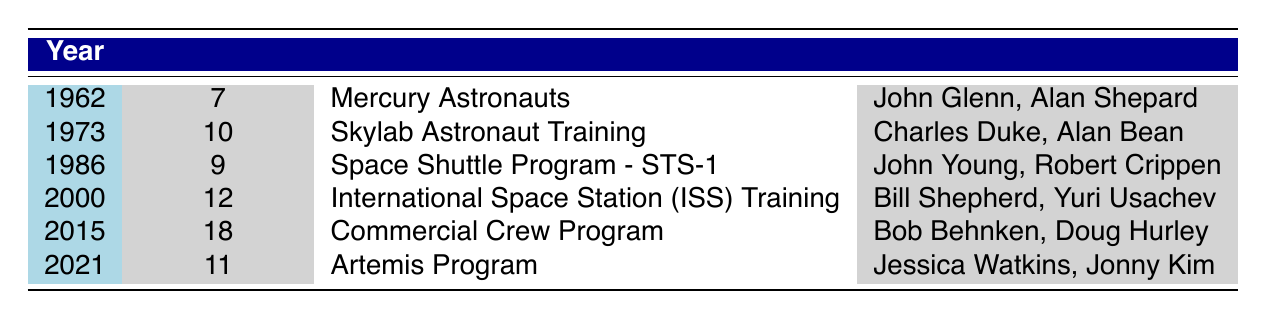What was the maximum number of participants in a single year? The maximum number in the "Participants" column is 18, which is found in the year 2015 under the "Commercial Crew Program."
Answer: 18 In which year did the Skylab Astronaut Training program have participants? The table indicates that the Skylab Astronaut Training program had participants in 1973.
Answer: 1973 What is the total number of participants across all programs from 1962 to 2021? To find this, sum the participants: 7 + 10 + 9 + 12 + 18 + 11 = 67.
Answer: 67 Were there more participants in the Artemis Program than the Space Shuttle Program - STS-1? Comparing 11 participants in the Artemis Program in 2021 to 9 participants in the Space Shuttle Program - STS-1 in 1986 shows that the Artemis Program had more participants.
Answer: Yes Which program had the least number of participants and in what year? The least number of participants is 7, occurring in 1962 under the "Mercury Astronauts" program.
Answer: Mercury Astronauts, 1962 How many more participants were there in the Commercial Crew Program than in the International Space Station (ISS) Training? The Commercial Crew Program had 18 participants compared to 12 in the ISS Training, which is a difference of 18 - 12 = 6.
Answer: 6 Which two notable astronauts were part of the Mercury Astronauts program? The notable astronauts listed under the Mercury Astronauts program are John Glenn and Alan Shepard.
Answer: John Glenn, Alan Shepard In which year was there a training program with the same number of participants as in 1986? The year 2000 also had 12 participants in the International Space Station (ISS) Training, showing it's the only year with the same number.
Answer: 2000 Was Alan Shepard part of the Commercial Crew Program? The notable astronauts listed under the Commercial Crew Program do not include Alan Shepard, so he was not part of this program.
Answer: No 